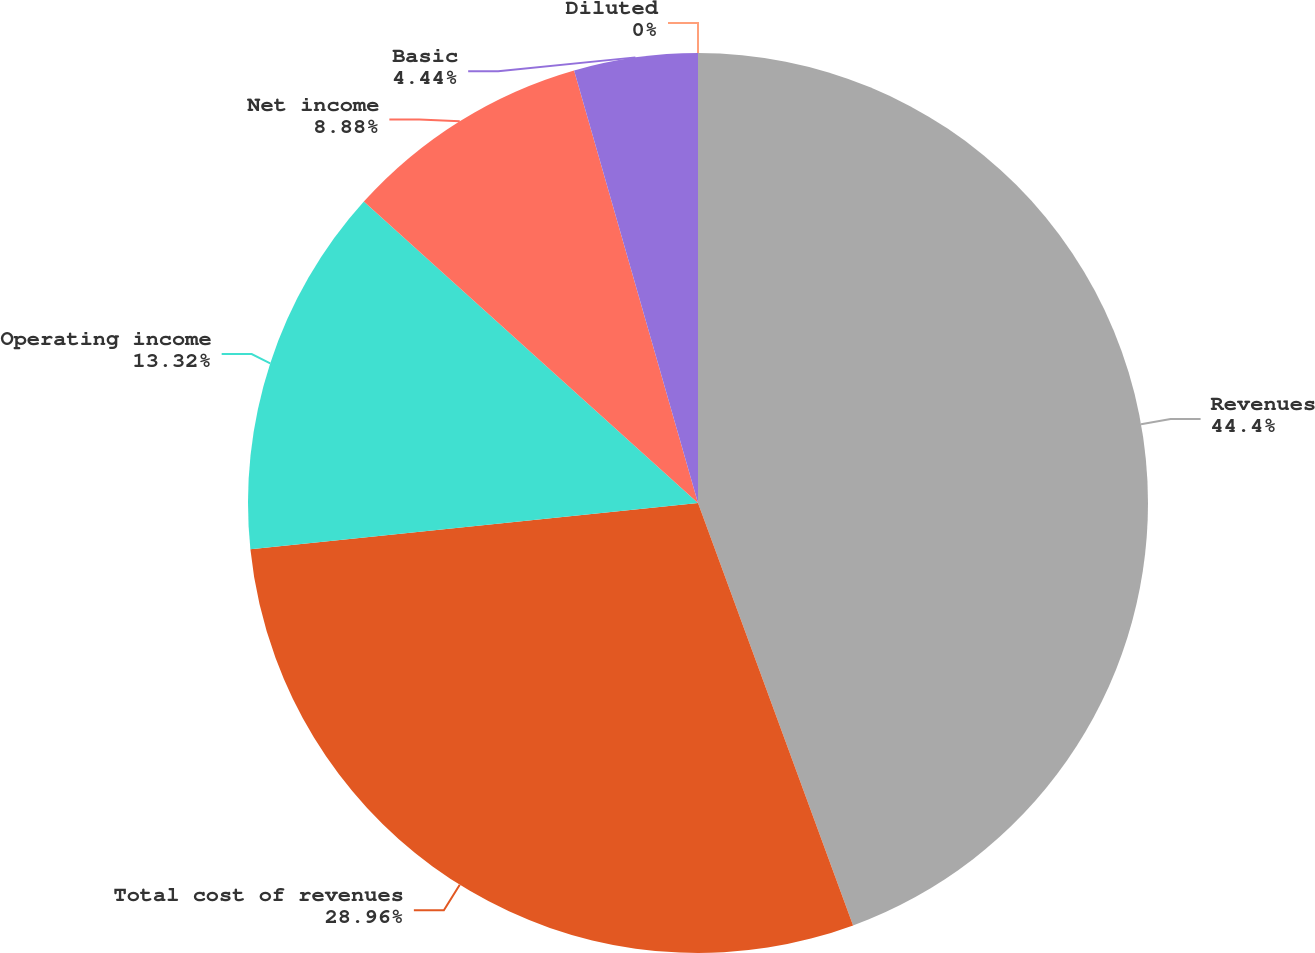Convert chart. <chart><loc_0><loc_0><loc_500><loc_500><pie_chart><fcel>Revenues<fcel>Total cost of revenues<fcel>Operating income<fcel>Net income<fcel>Basic<fcel>Diluted<nl><fcel>44.4%<fcel>28.96%<fcel>13.32%<fcel>8.88%<fcel>4.44%<fcel>0.0%<nl></chart> 